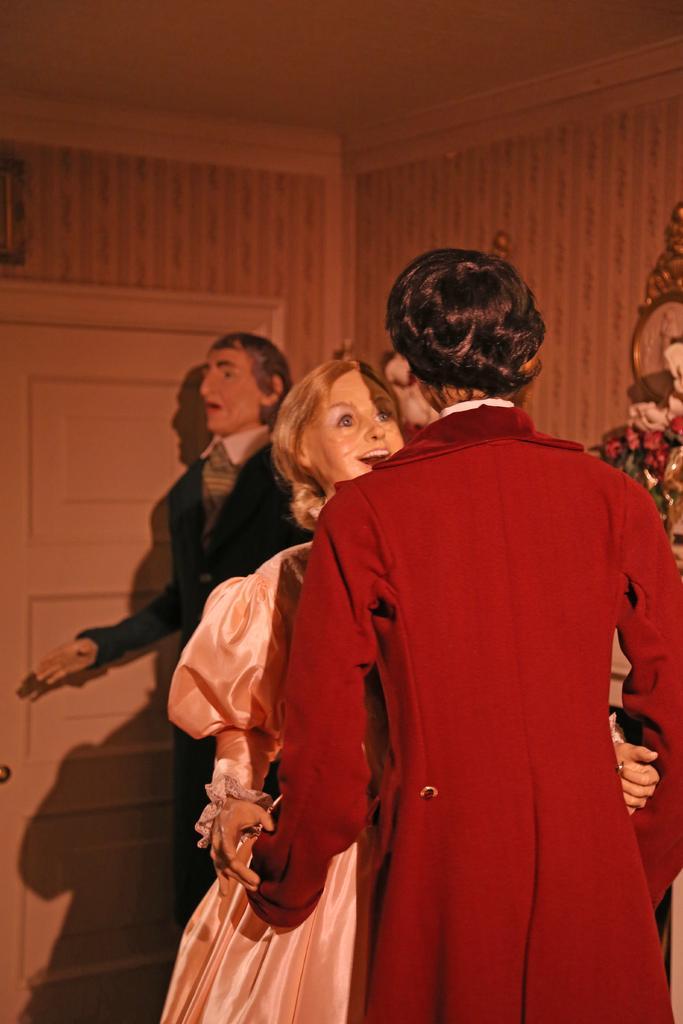In one or two sentences, can you explain what this image depicts? In this picture we can see the mannequins. In the background of the image we can see the wall, door and some other objects. At the top of the image we can see the roof. 